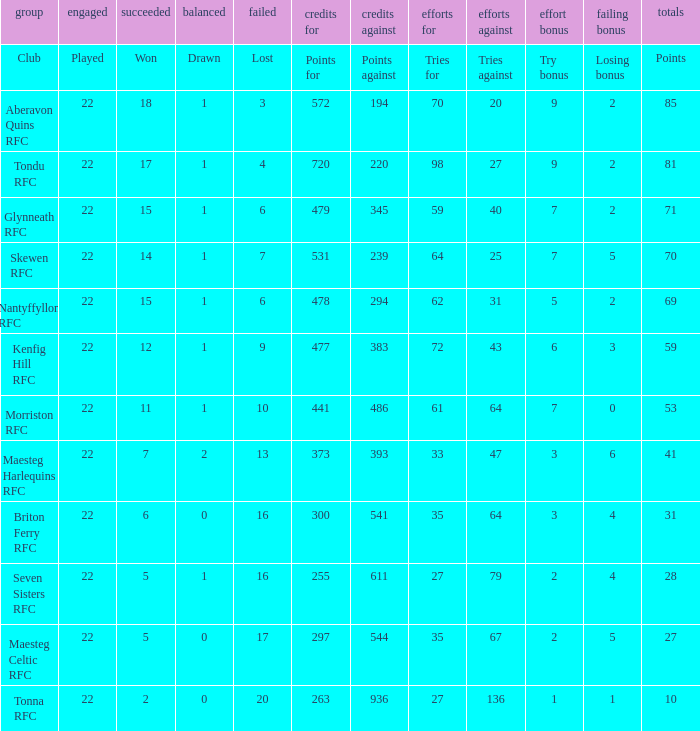How many tries against got the club with 62 tries for? 31.0. 